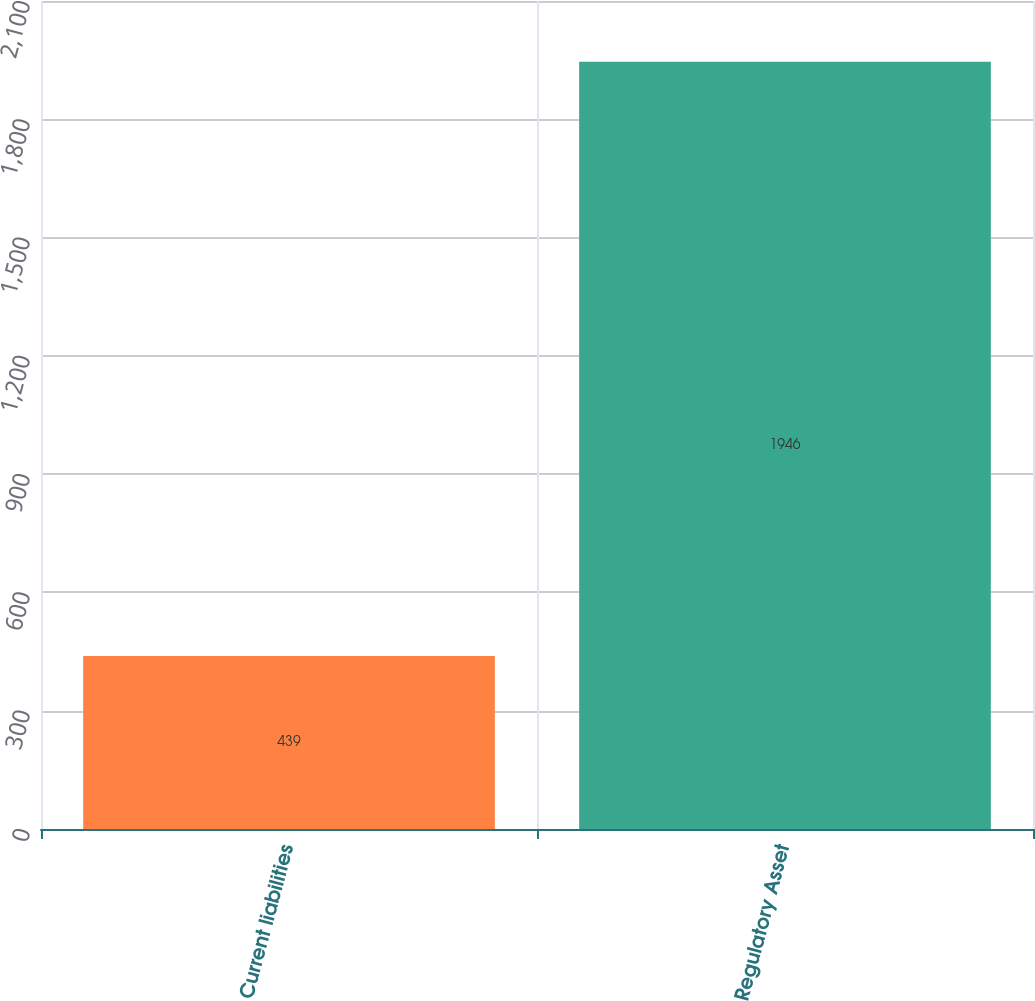Convert chart to OTSL. <chart><loc_0><loc_0><loc_500><loc_500><bar_chart><fcel>Current liabilities<fcel>Regulatory Asset<nl><fcel>439<fcel>1946<nl></chart> 